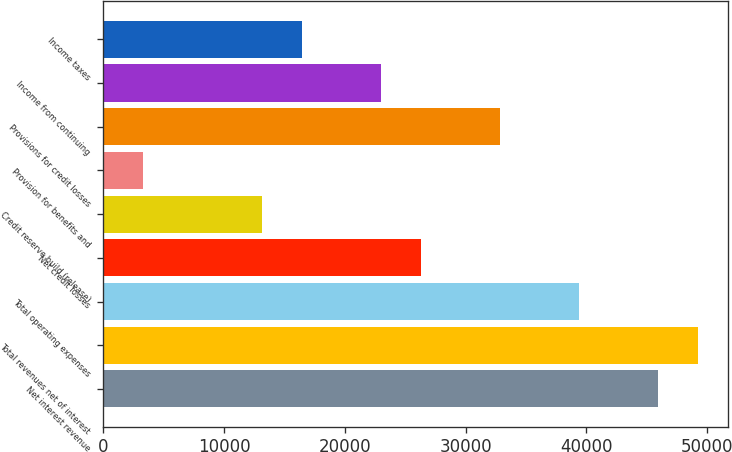Convert chart. <chart><loc_0><loc_0><loc_500><loc_500><bar_chart><fcel>Net interest revenue<fcel>Total revenues net of interest<fcel>Total operating expenses<fcel>Net credit losses<fcel>Credit reserve build (release)<fcel>Provision for benefits and<fcel>Provisions for credit losses<fcel>Income from continuing<fcel>Income taxes<nl><fcel>45969.6<fcel>49252.5<fcel>39403.8<fcel>26272.2<fcel>13140.6<fcel>3291.9<fcel>32838<fcel>22989.3<fcel>16423.5<nl></chart> 